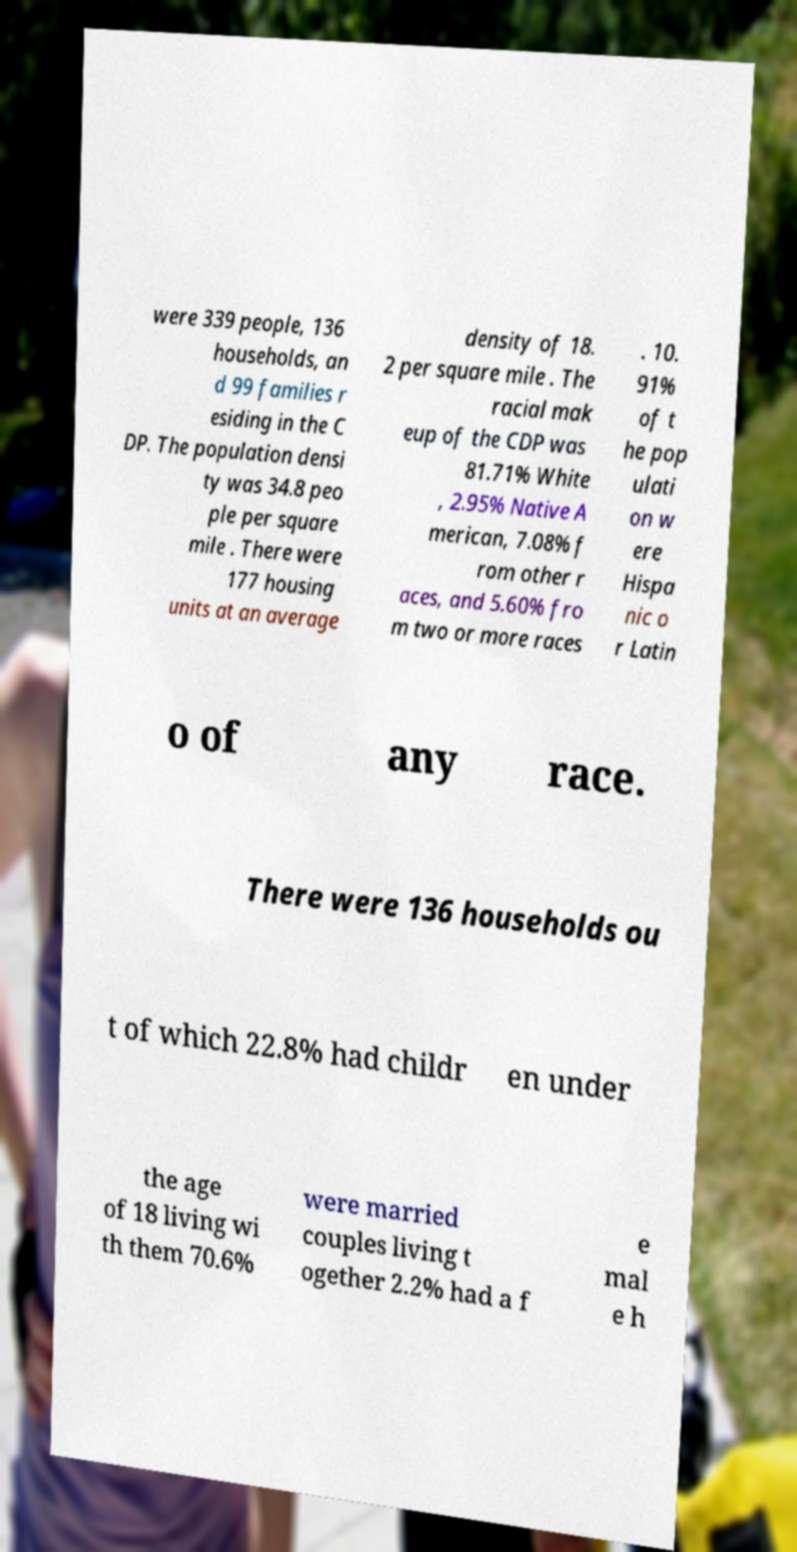Please read and relay the text visible in this image. What does it say? were 339 people, 136 households, an d 99 families r esiding in the C DP. The population densi ty was 34.8 peo ple per square mile . There were 177 housing units at an average density of 18. 2 per square mile . The racial mak eup of the CDP was 81.71% White , 2.95% Native A merican, 7.08% f rom other r aces, and 5.60% fro m two or more races . 10. 91% of t he pop ulati on w ere Hispa nic o r Latin o of any race. There were 136 households ou t of which 22.8% had childr en under the age of 18 living wi th them 70.6% were married couples living t ogether 2.2% had a f e mal e h 